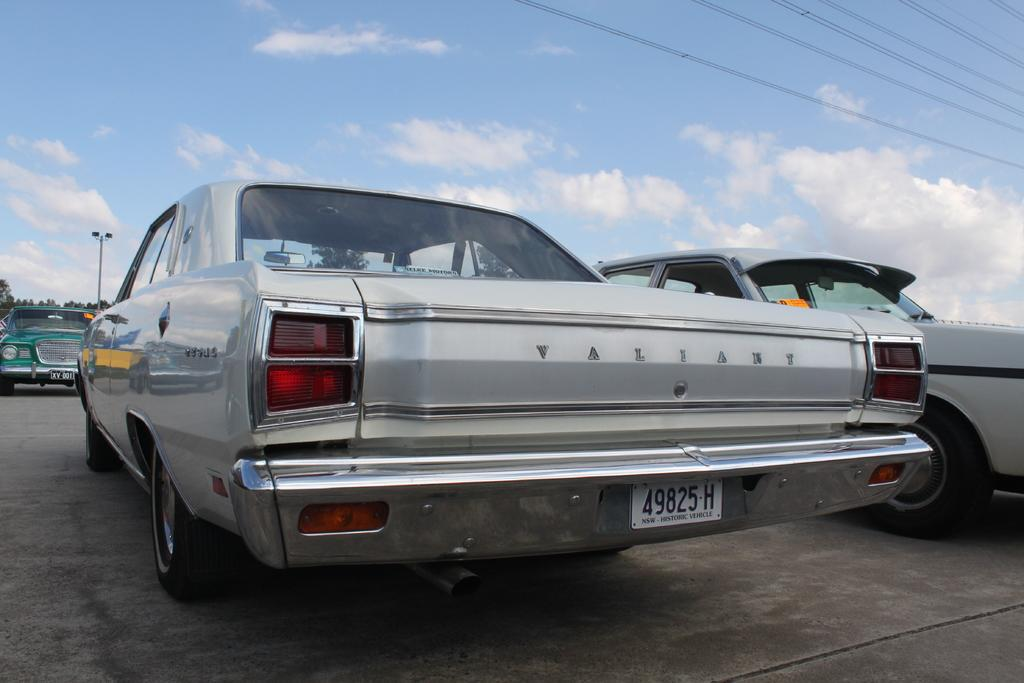What can be seen on the road in the image? There are vehicles parked on the road in the image. How many vehicles are parked on the road, and what can be said about their colors? There are multiple vehicles parked on the road, and they are in different colors. What is visible in the background of the image? In the background, there are electrical lines, trees, and clouds in the blue sky. How many lizards can be seen crawling on the vehicles in the image? There are no lizards visible in the image; it only shows vehicles parked on the road. What type of error is present in the image? There is no error present in the image; it appears to be a clear and accurate representation of the scene. 